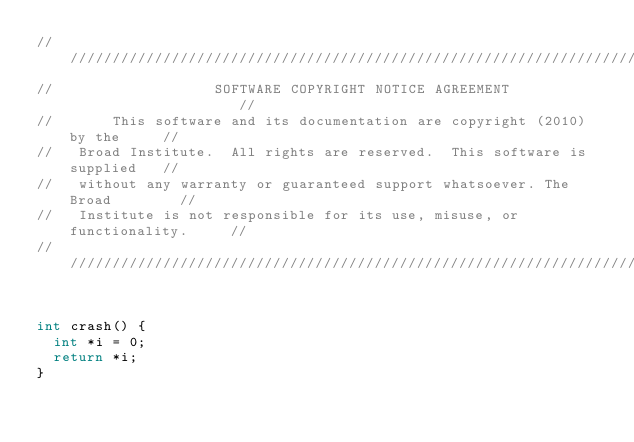Convert code to text. <code><loc_0><loc_0><loc_500><loc_500><_C++_>///////////////////////////////////////////////////////////////////////////////
//                   SOFTWARE COPYRIGHT NOTICE AGREEMENT                     //
//       This software and its documentation are copyright (2010) by the     //
//   Broad Institute.  All rights are reserved.  This software is supplied   //
//   without any warranty or guaranteed support whatsoever. The Broad        //
//   Institute is not responsible for its use, misuse, or functionality.     //
///////////////////////////////////////////////////////////////////////////////


int crash() {
  int *i = 0;
  return *i;
}
</code> 